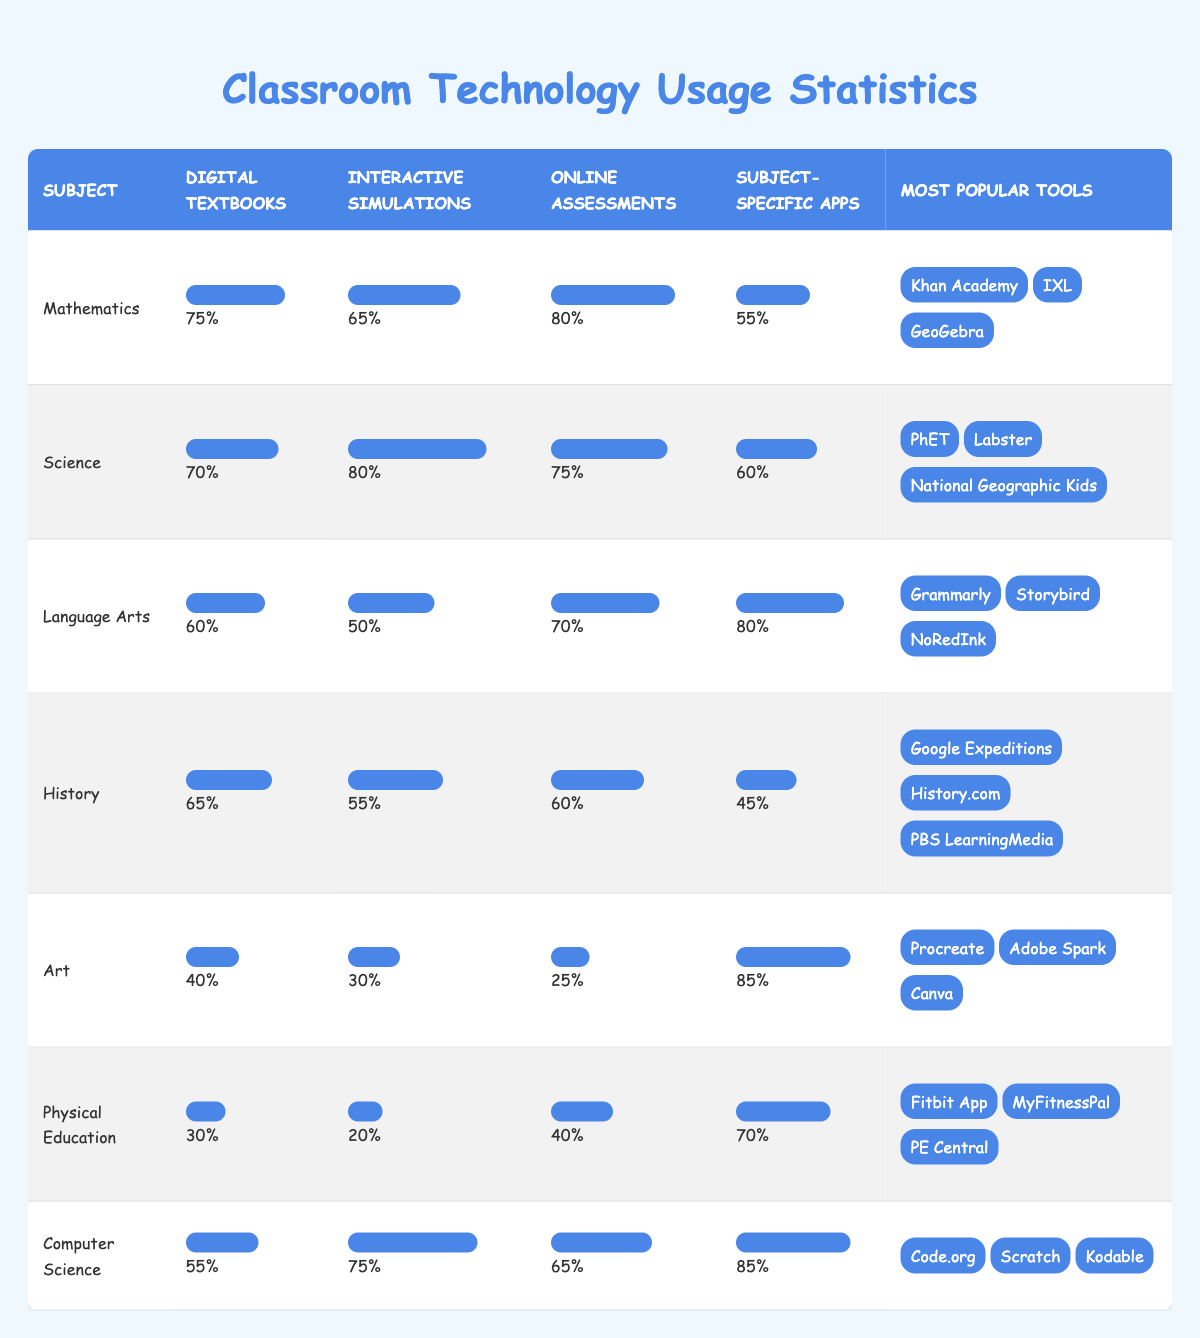What is the usage percentage of Digital Textbooks in Science? The usage percentage for Digital Textbooks in Science can be found in the table, which shows a value of 70%.
Answer: 70% Which subject area has the highest percentage of Online Assessments usage? By comparing the values in the Online Assessments column, Mathematics has the highest percentage at 80%.
Answer: Mathematics What is the most popular tool for Language Arts? The most popular tools for Language Arts are listed in the table, with Grammarly being the first mentioned tool.
Answer: Grammarly Is the usage percentage of Interactive Simulations in Art higher than in History? Art has a usage percentage of 30% for Interactive Simulations, while History has 55%, making History higher.
Answer: No Calculate the average usage percentage of Creative Apps across all subjects. The only subject that uses Creative Apps is Art, with a usage percentage of 85%. Since there’s only one value, the average is also 85%.
Answer: 85 What is the difference in usage percentage of Online Assessments between Mathematics and Physical Education? Mathematics has an Online Assessments usage percentage of 80% and Physical Education has 40%. The difference is 80% - 40% = 40%.
Answer: 40% Which subject has the lowest usage percentage for Digital Textbooks? By examining the Digital Textbooks column, Physical Education shows the lowest percentage at 30%.
Answer: Physical Education Are Fitness Apps more used in Physical Education than Creative Apps in Art? Fitness Apps usage is at 70% in Physical Education while Creative Apps in Art is at 85%. Thus, Creative Apps is used more.
Answer: No What is the total usage percentage of Interactive Simulations across all subjects? The total is calculated by adding the individual usage percentages: 65 (Math) + 80 (Science) + 50 (Language Arts) + 55 (History) + 30 (Art) + 20 (PE) + 75 (CS) = 375%.
Answer: 375% Which subject area has a higher overall technology usage percentage: Mathematics or Computer Science? To compare, we can average the percentages for both subjects. Mathematics: (75 + 65 + 80 + 55) / 4 = 68.75. Computer Science: (55 + 75 + 65 + 85) / 4 = 70. So, Computer Science has a higher average.
Answer: Computer Science 